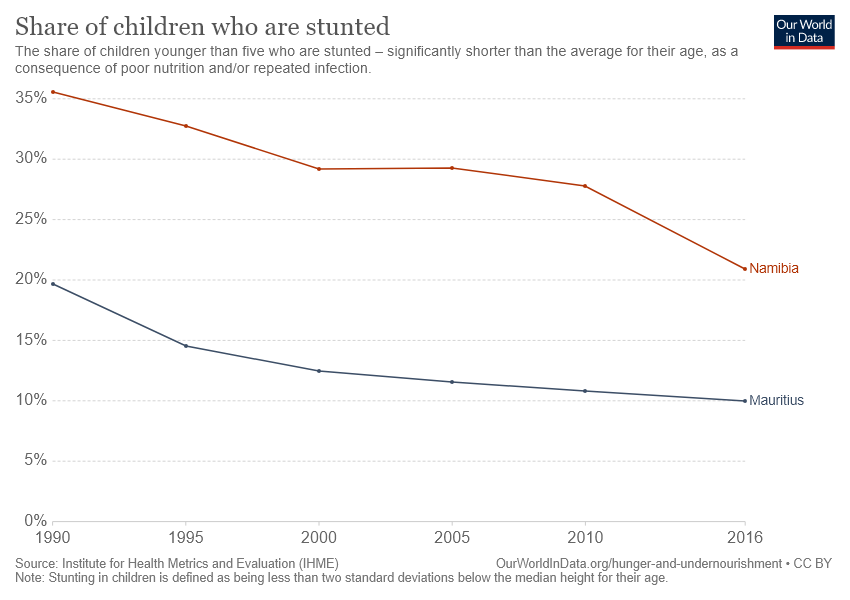Highlight a few significant elements in this photo. The graph presents the geographical regions of Namibia and Mauritius. The share of children who were stunted in the year 2000 was below 10%. 